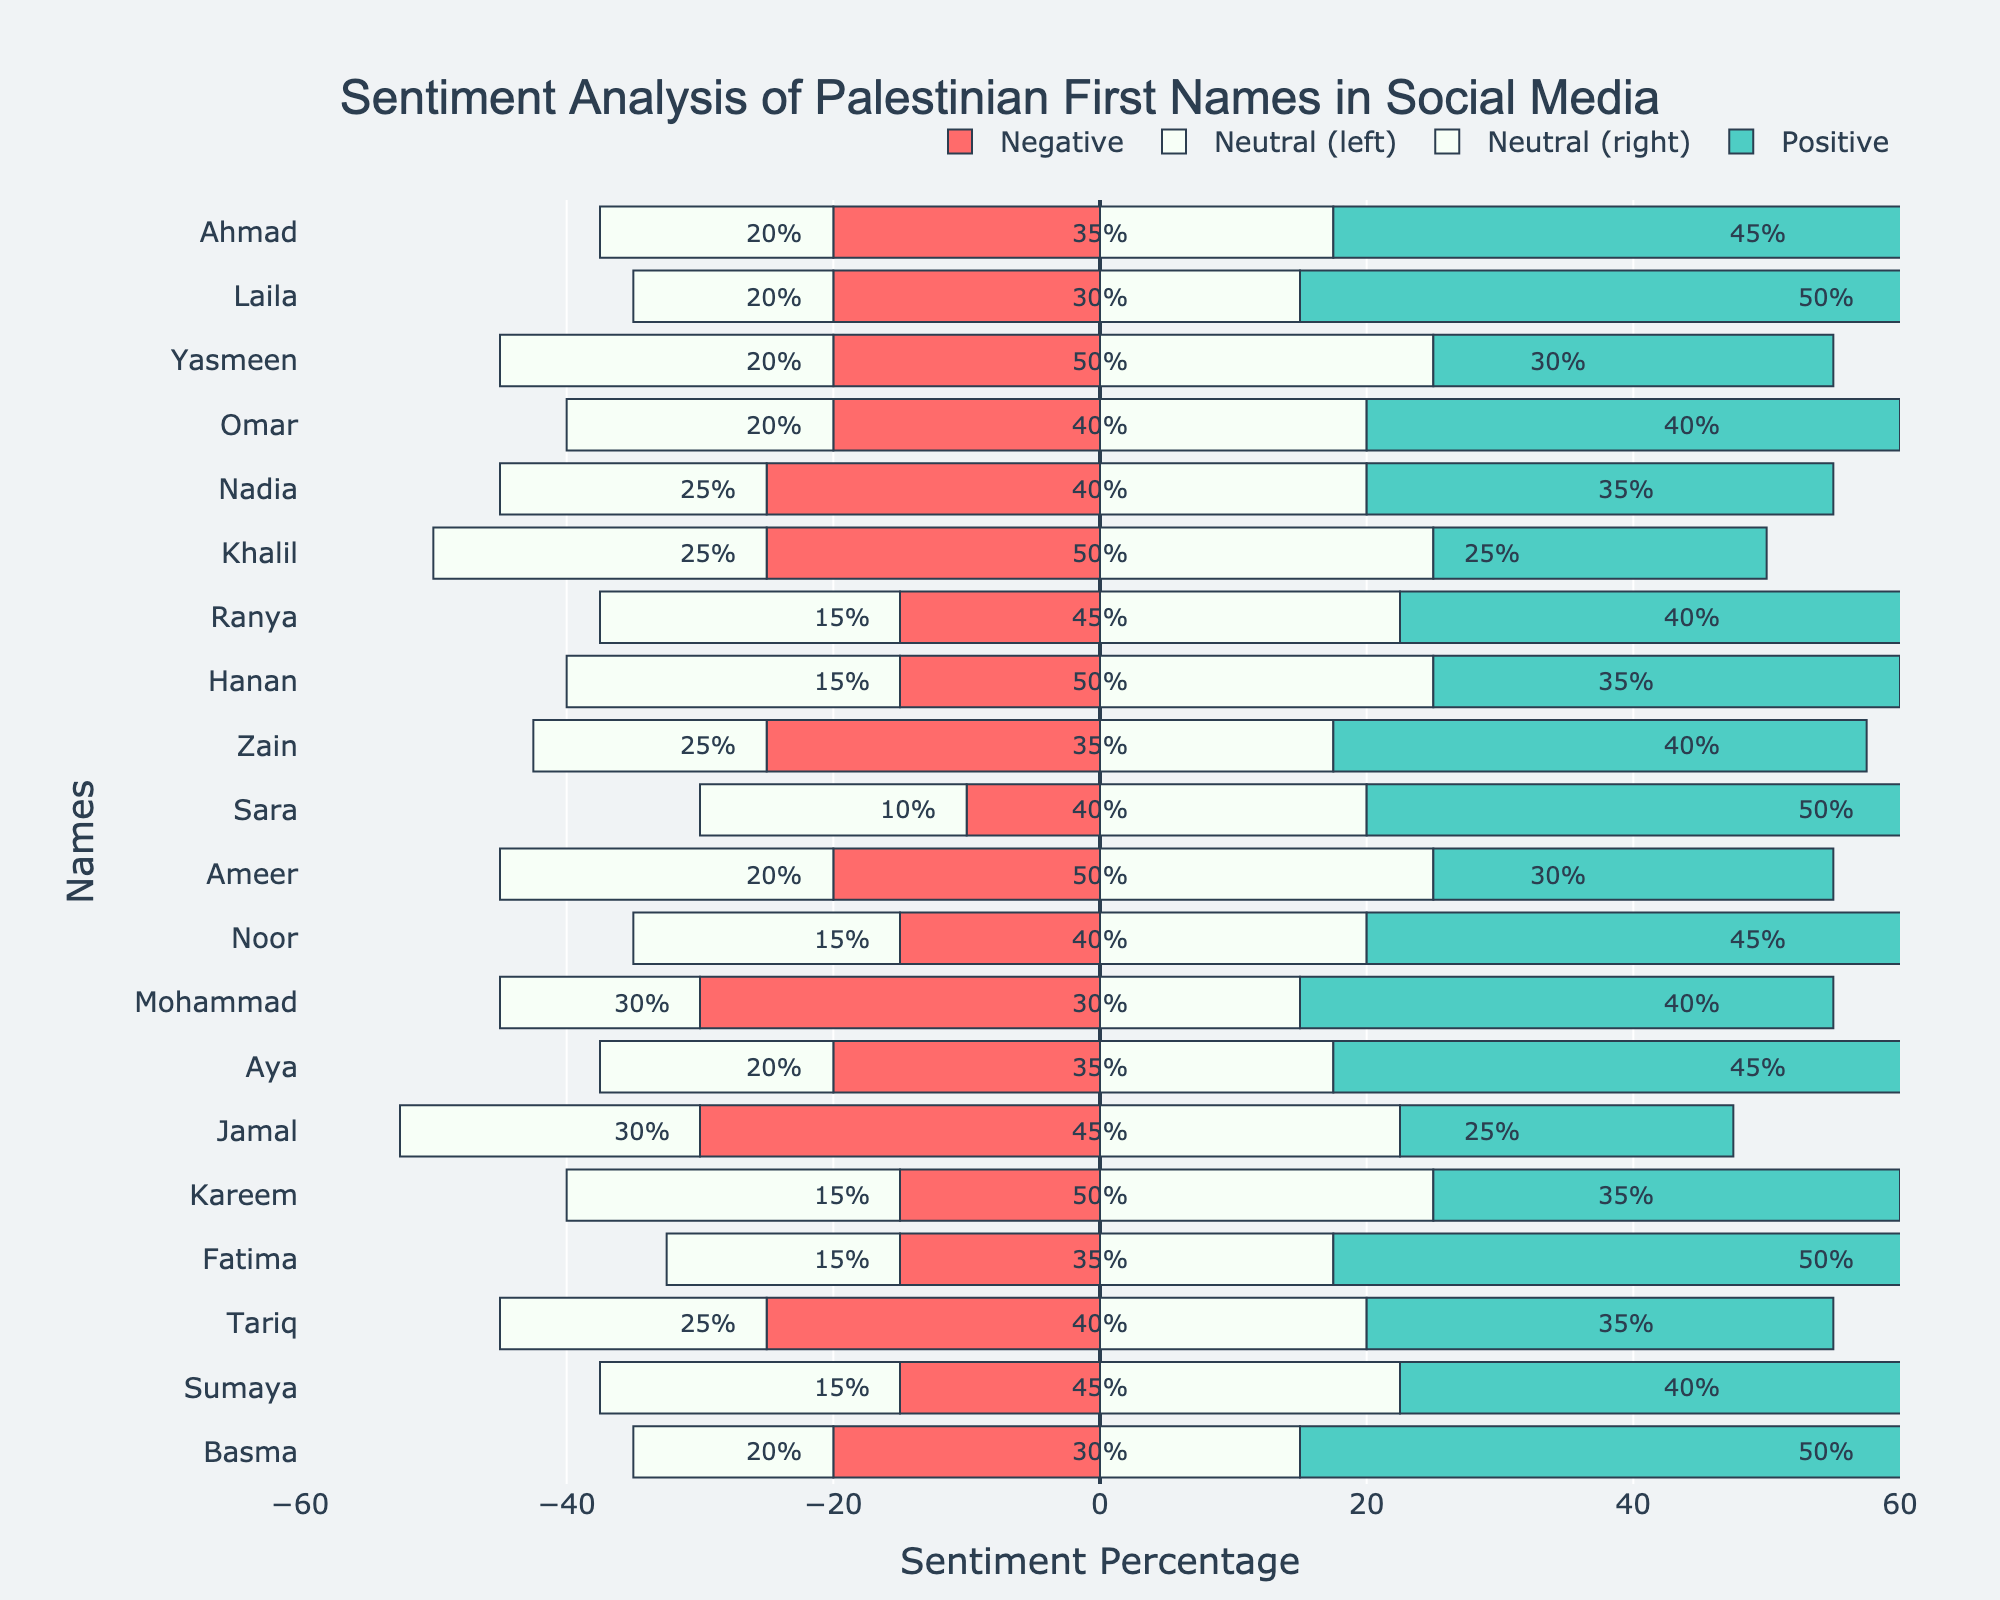What's the name with the highest positive sentiment? The highest positive sentiment can be found by looking at the lengths of the green bars. The longest green bar corresponds to 'Laila', 'Sara', 'Fatima', and 'Basma', all with 50% positive sentiment.
Answer: Laila, Sara, Fatima, Basma Which name has the highest negative sentiment? The highest negative sentiment is represented by the longest red bar. The longest red bar corresponds to 'Mohammad', which has 30% negative sentiment.
Answer: Mohammad Which names have exactly 50% neutral sentiment? To determine which names have 50% neutral sentiment, we check the bars around the center line and read the percentage labels provided for the neutral sentiment. The names with 50% neutral sentiment are 'Yasmeen', 'Khalil', 'Hanan', 'Ameer', and 'Kareem'.
Answer: Yasmeen, Khalil, Hanan, Ameer, Kareem What is the combined percentage of positive and neutral sentiment for 'Omar'? For 'Omar', the positive sentiment is 40% and the neutral sentiment is also 40%. Adding these together gives 40% + 40% = 80%.
Answer: 80% Which two names have the same sentiment distribution? By observing the lengths of the bars for positive, neutral, and negative sentiments for each name, 'Laila' and 'Basma' are the names with the same sentiment distribution: Positive 50%, Neutral 30%, Negative 20%.
Answer: Laila, Basma What is the average negative sentiment for all names? To calculate the average negative sentiment, sum up all the negative sentiment percentages and divide by the number of names. The sum is 20+20+20+20+25+25+15+15+25+10+20+15+30+20+30+15+15+25+15+20 = 405. There are 20 names. The average is 405/20 = 20.25%.
Answer: 20.25% Which name has the most balanced distribution between all three sentiments? The most balanced distribution has equally long bars for all three sentiments. 'Khalil' stands out with 25% positive, 50% neutral, and 25% negative, as these values are closest to being evenly distributed.
Answer: Khalil Compare the positive sentiment of 'Ahmad' and 'Aya'. The positive sentiment for 'Ahmad' is 45%, while for 'Aya' it is 45%. Thus, both have the same positive sentiment.
Answer: Equal Which name has the smallest neutral sentiment percentage, and what is that percentage? The smallest neutral sentiment percentage is represented by the smallest white bar. The smallest neutral sentiment is 30%, which is shared by 'Laila', 'Basma', 'Mohammad', and 'Fatima'.
Answer: 30% What is the total positive sentiment for the names that have more than 45% in positive sentiment? The names with more than 45% positive sentiment are 'Laila', 'Sara', 'Fatima', and 'Basma', each with 50%. The total positive sentiment is 50 + 50 + 50 + 50 = 200%.
Answer: 200% 